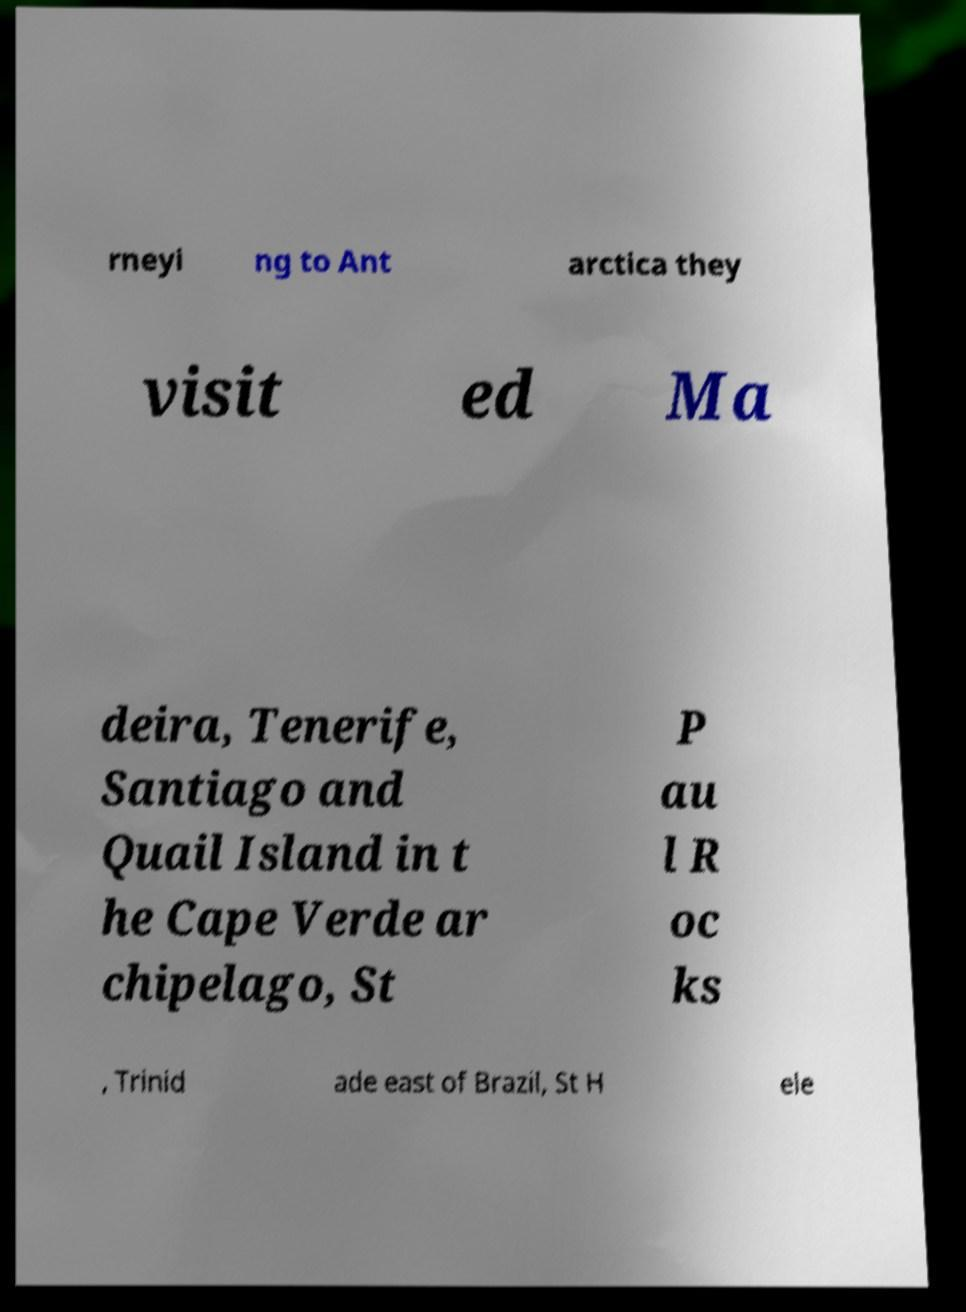Please read and relay the text visible in this image. What does it say? rneyi ng to Ant arctica they visit ed Ma deira, Tenerife, Santiago and Quail Island in t he Cape Verde ar chipelago, St P au l R oc ks , Trinid ade east of Brazil, St H ele 